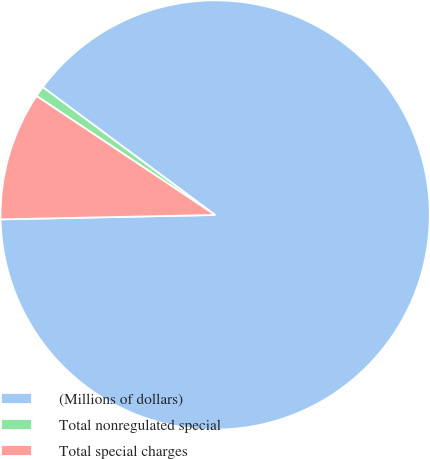<chart> <loc_0><loc_0><loc_500><loc_500><pie_chart><fcel>(Millions of dollars)<fcel>Total nonregulated special<fcel>Total special charges<nl><fcel>89.52%<fcel>0.8%<fcel>9.68%<nl></chart> 